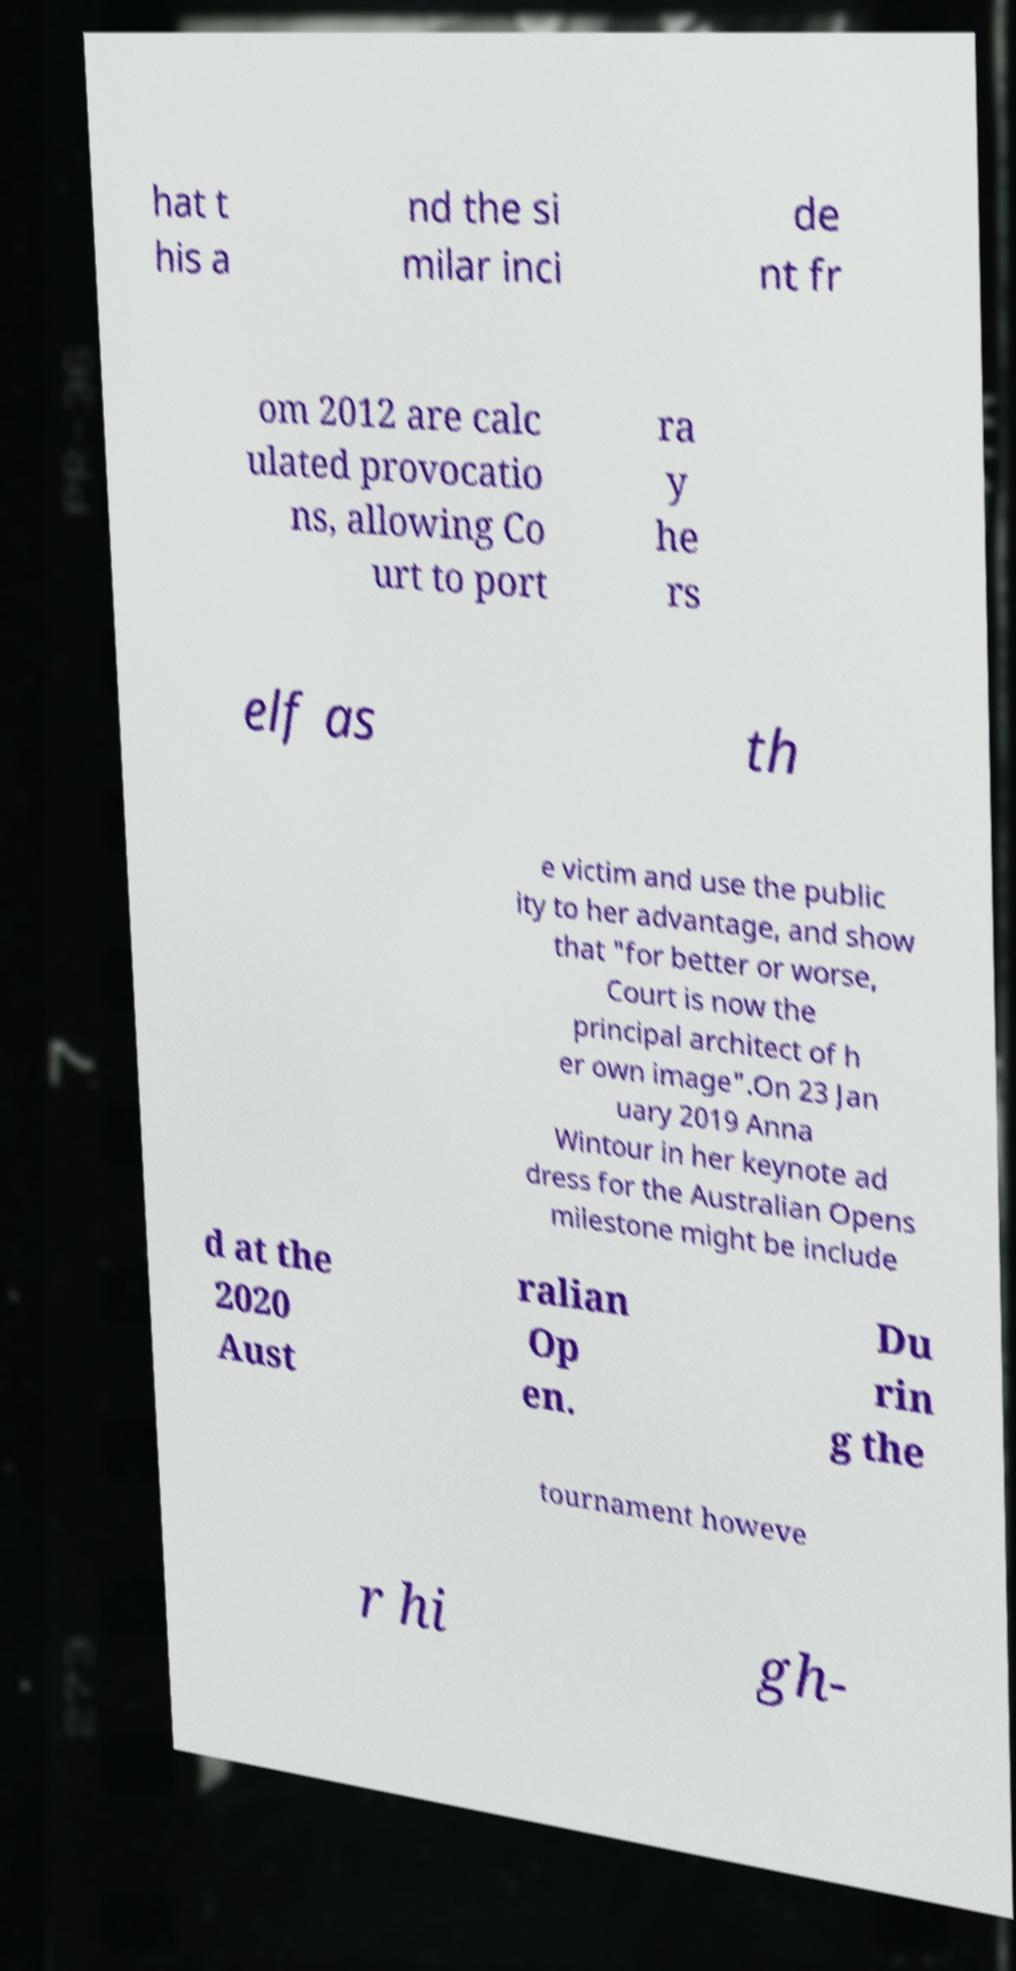What messages or text are displayed in this image? I need them in a readable, typed format. hat t his a nd the si milar inci de nt fr om 2012 are calc ulated provocatio ns, allowing Co urt to port ra y he rs elf as th e victim and use the public ity to her advantage, and show that "for better or worse, Court is now the principal architect of h er own image".On 23 Jan uary 2019 Anna Wintour in her keynote ad dress for the Australian Opens milestone might be include d at the 2020 Aust ralian Op en. Du rin g the tournament howeve r hi gh- 